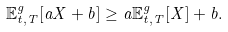<formula> <loc_0><loc_0><loc_500><loc_500>\mathbb { E } _ { t , T } ^ { g } [ a X + b ] \geq a \mathbb { E } _ { t , T } ^ { g } [ X ] + b .</formula> 